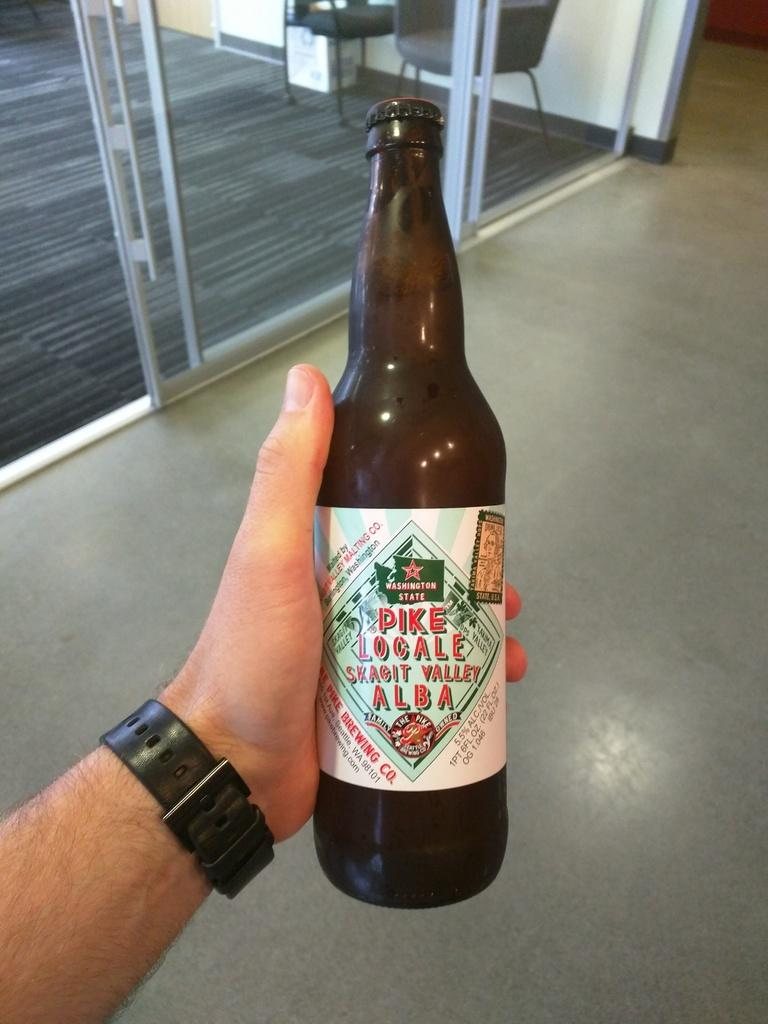<image>
Relay a brief, clear account of the picture shown. man with a watch holding a bottle of pike local beer 